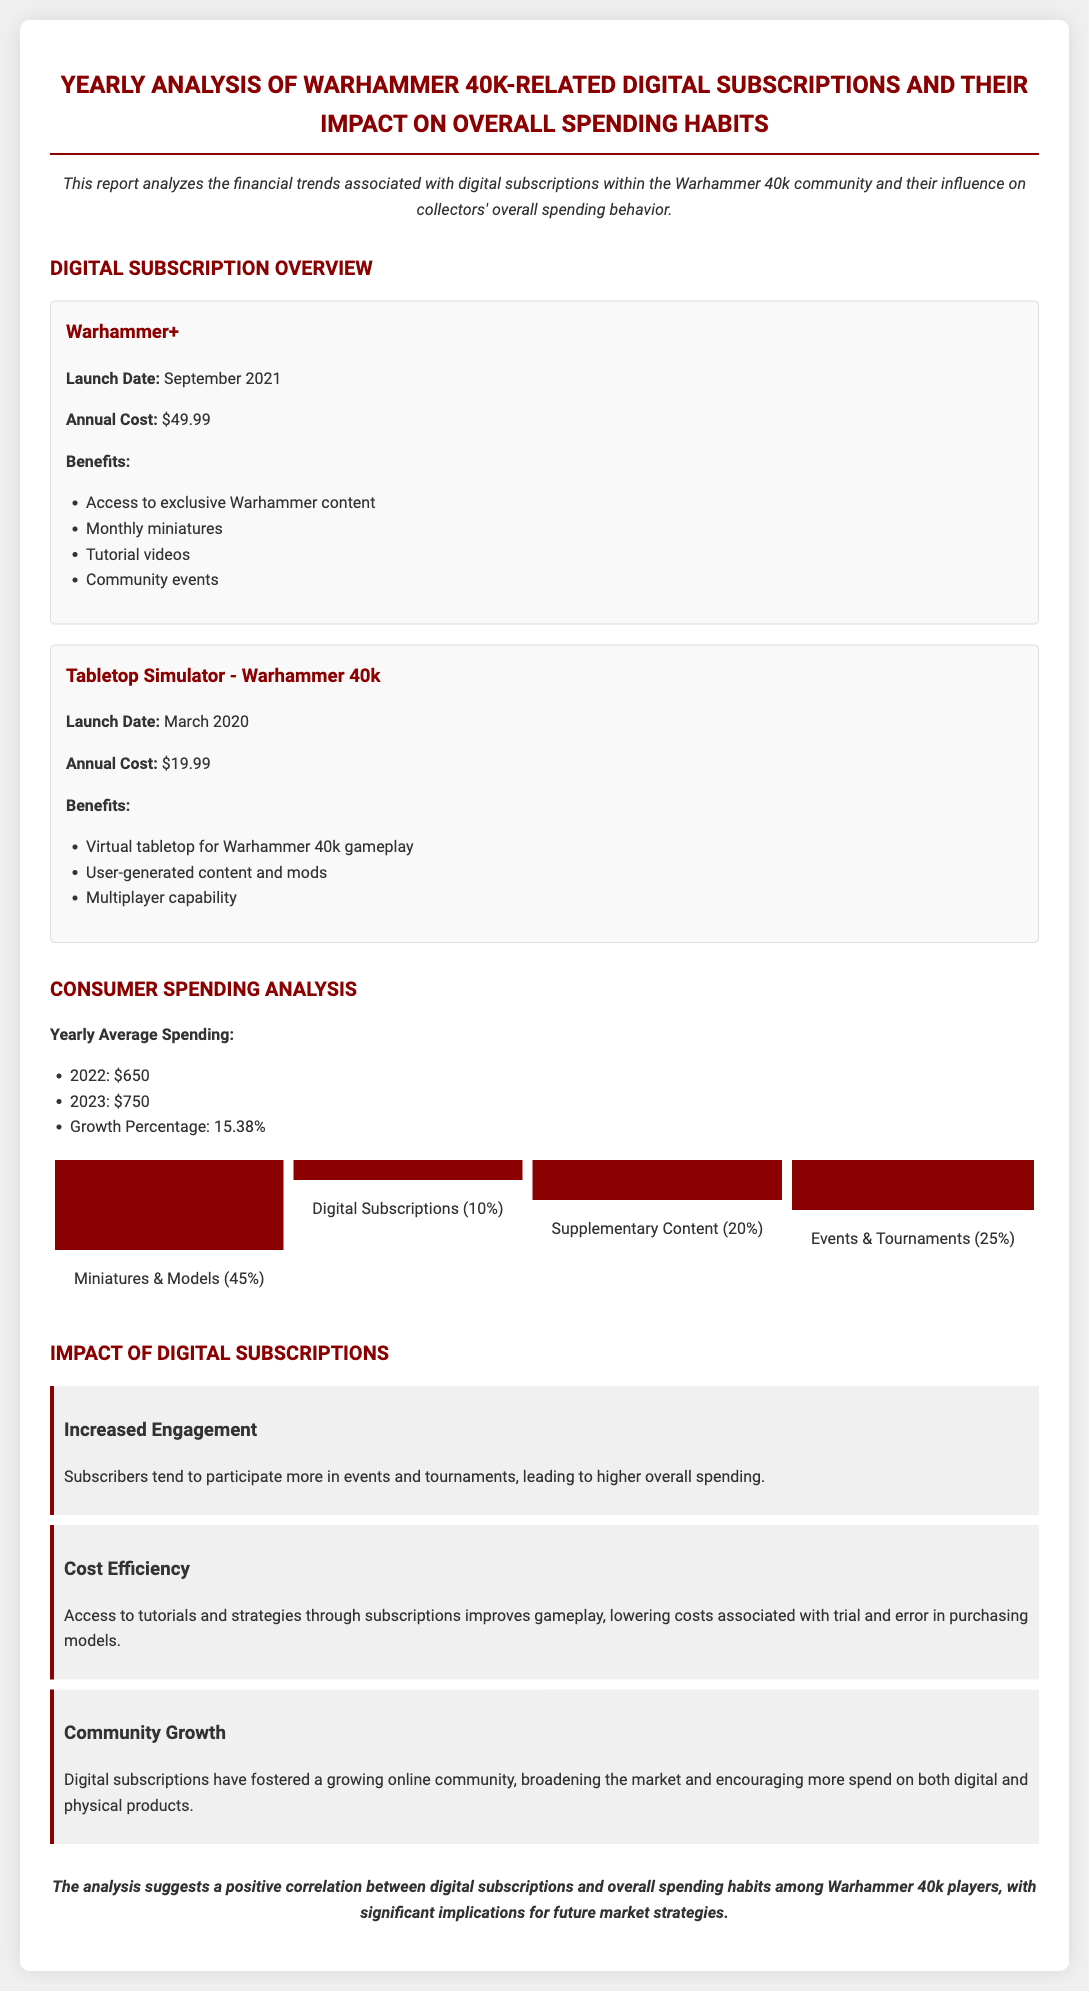What is the launch date of Warhammer+? The launch date of Warhammer+ is September 2021.
Answer: September 2021 What is the annual cost of Tabletop Simulator - Warhammer 40k? The annual cost of Tabletop Simulator - Warhammer 40k is $19.99.
Answer: $19.99 What was the yearly average spending in 2023? The yearly average spending in 2023 is $750.
Answer: $750 What percentage of spending is dedicated to digital subscriptions? Digital subscriptions account for 10% of total spending.
Answer: 10% What growth percentage did average spending see from 2022 to 2023? The growth percentage in average spending from 2022 to 2023 is 15.38%.
Answer: 15.38% What impact do digital subscriptions have on consumer spending behavior? Digital subscriptions have a positive correlation with overall spending habits among players.
Answer: Positive correlation Which category received the highest percentage of consumer spending? The highest percentage of consumer spending is on miniatures and models at 45%.
Answer: Miniatures & Models (45%) What benefit do subscribers gain in terms of cost efficiency? Subscribers benefit from improved gameplay, reducing trial and error costs.
Answer: Improved gameplay Which community aspect has grown due to digital subscriptions? Digital subscriptions have fostered a growing online community.
Answer: Growing online community 